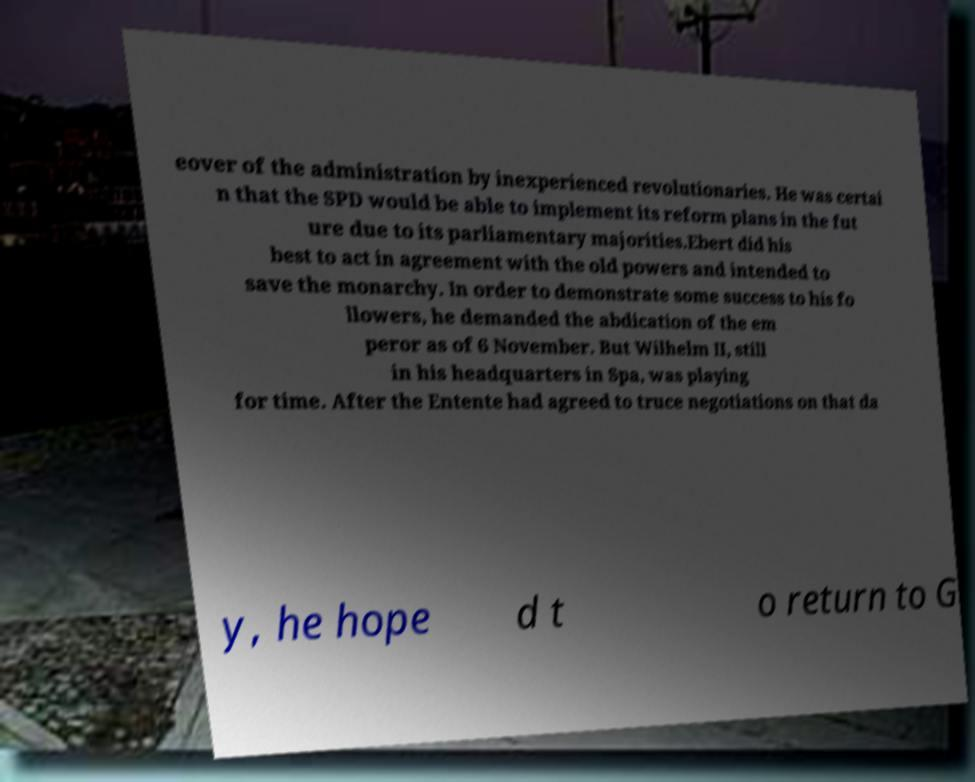There's text embedded in this image that I need extracted. Can you transcribe it verbatim? eover of the administration by inexperienced revolutionaries. He was certai n that the SPD would be able to implement its reform plans in the fut ure due to its parliamentary majorities.Ebert did his best to act in agreement with the old powers and intended to save the monarchy. In order to demonstrate some success to his fo llowers, he demanded the abdication of the em peror as of 6 November. But Wilhelm II, still in his headquarters in Spa, was playing for time. After the Entente had agreed to truce negotiations on that da y, he hope d t o return to G 